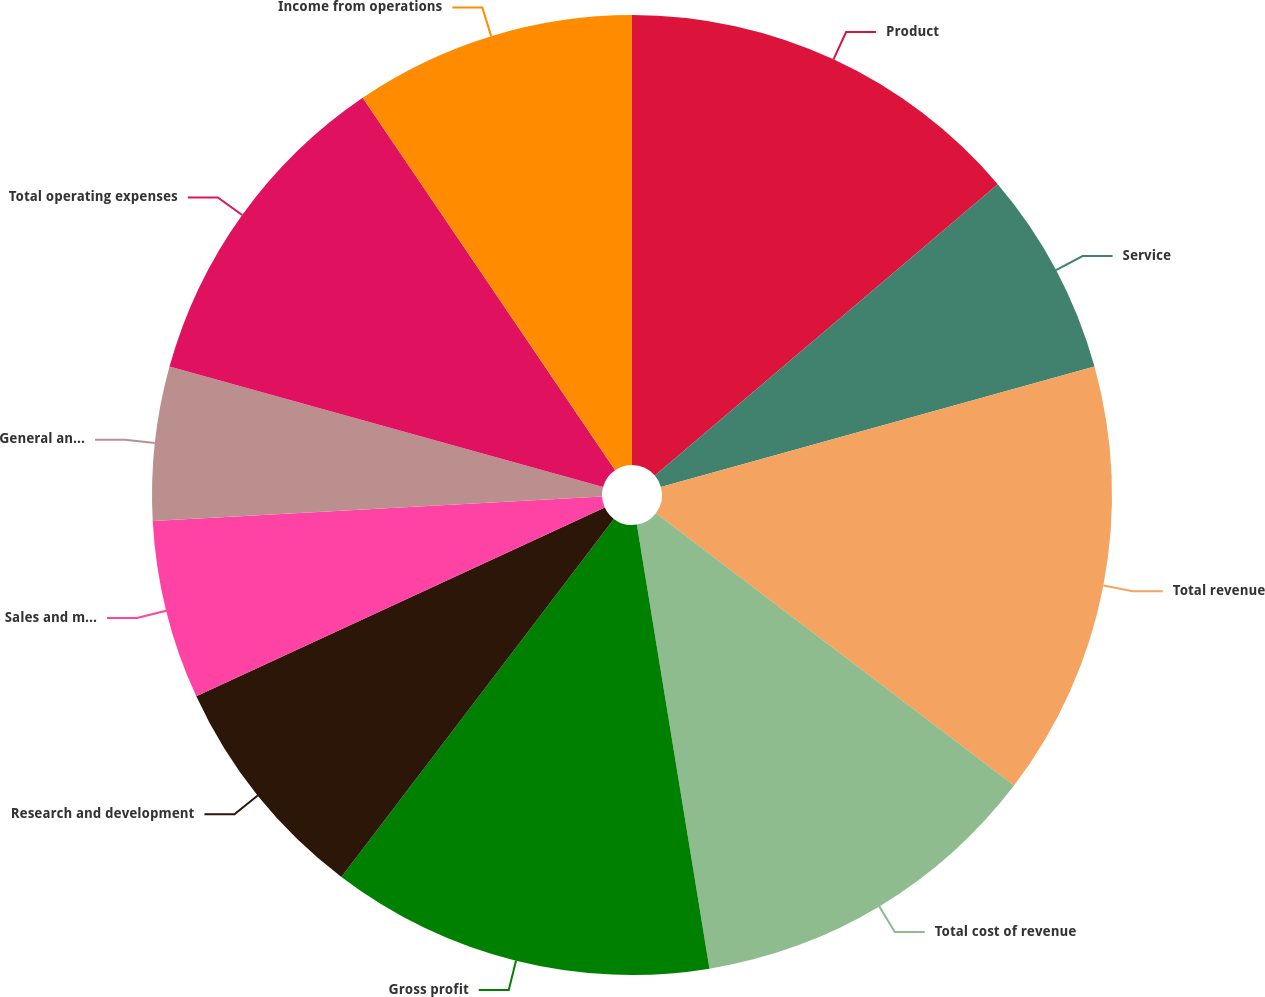<chart> <loc_0><loc_0><loc_500><loc_500><pie_chart><fcel>Product<fcel>Service<fcel>Total revenue<fcel>Total cost of revenue<fcel>Gross profit<fcel>Research and development<fcel>Sales and marketing<fcel>General and administrative<fcel>Total operating expenses<fcel>Income from operations<nl><fcel>13.79%<fcel>6.9%<fcel>14.66%<fcel>12.07%<fcel>12.93%<fcel>7.76%<fcel>6.03%<fcel>5.17%<fcel>11.21%<fcel>9.48%<nl></chart> 